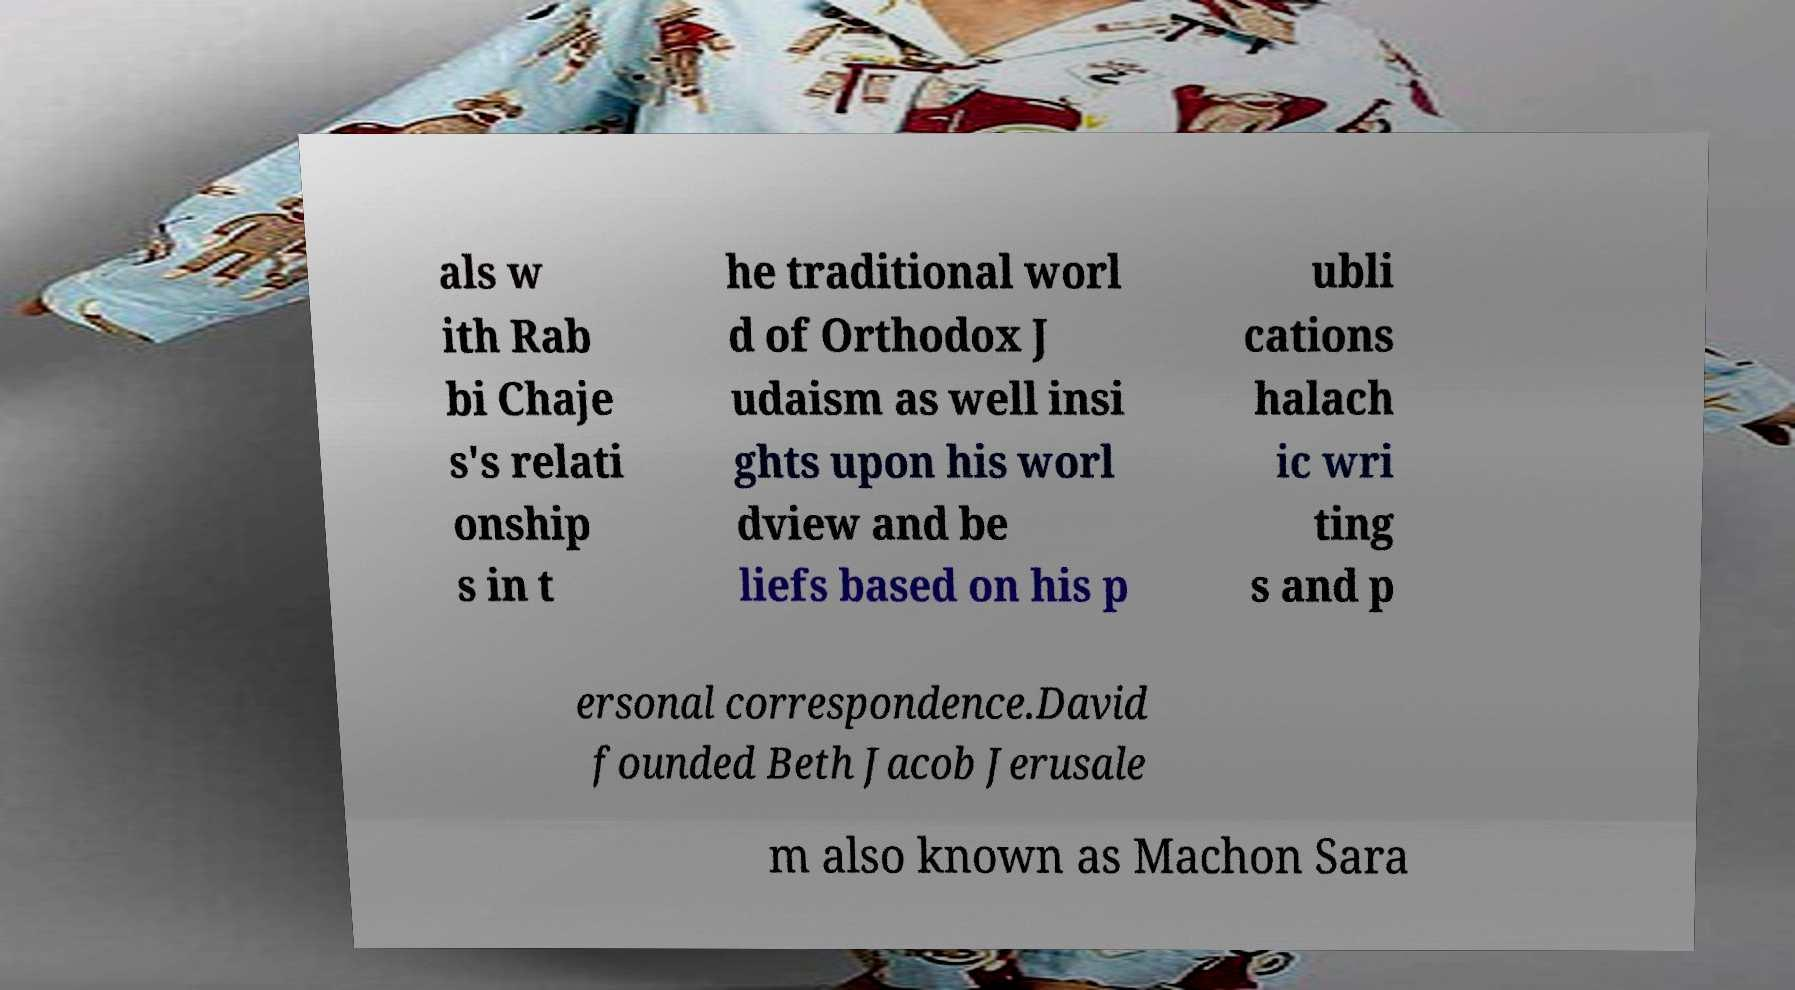Please read and relay the text visible in this image. What does it say? als w ith Rab bi Chaje s's relati onship s in t he traditional worl d of Orthodox J udaism as well insi ghts upon his worl dview and be liefs based on his p ubli cations halach ic wri ting s and p ersonal correspondence.David founded Beth Jacob Jerusale m also known as Machon Sara 